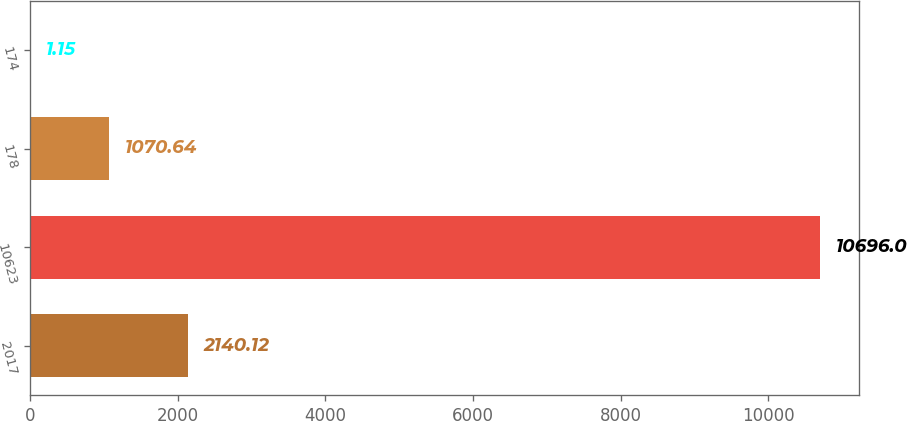<chart> <loc_0><loc_0><loc_500><loc_500><bar_chart><fcel>2017<fcel>10623<fcel>178<fcel>174<nl><fcel>2140.12<fcel>10696<fcel>1070.64<fcel>1.15<nl></chart> 